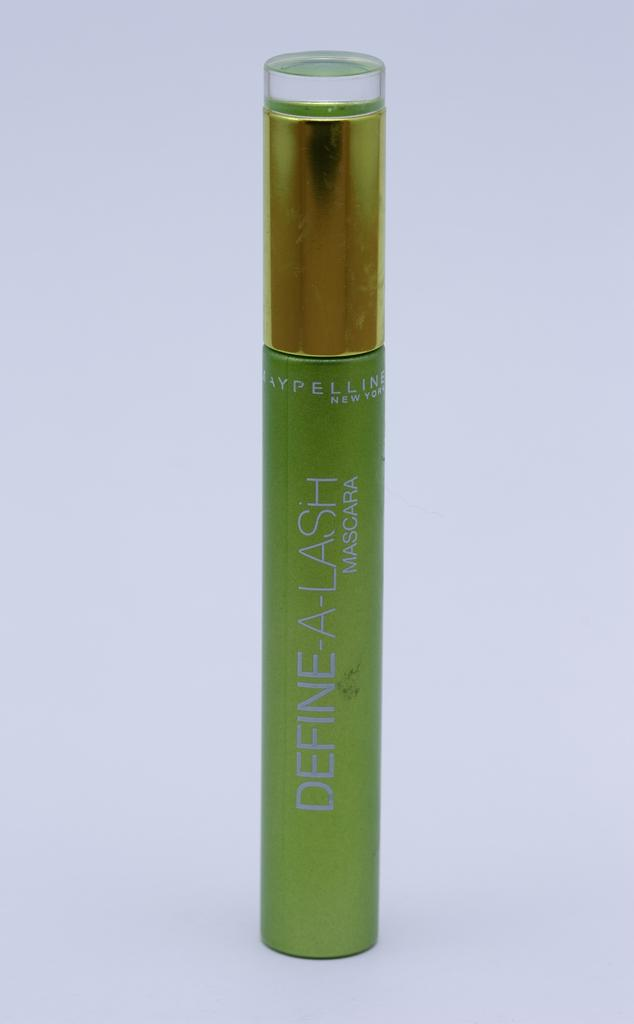<image>
Render a clear and concise summary of the photo. A mascara product with the words "Define-A-Lash" printed down the middle. 